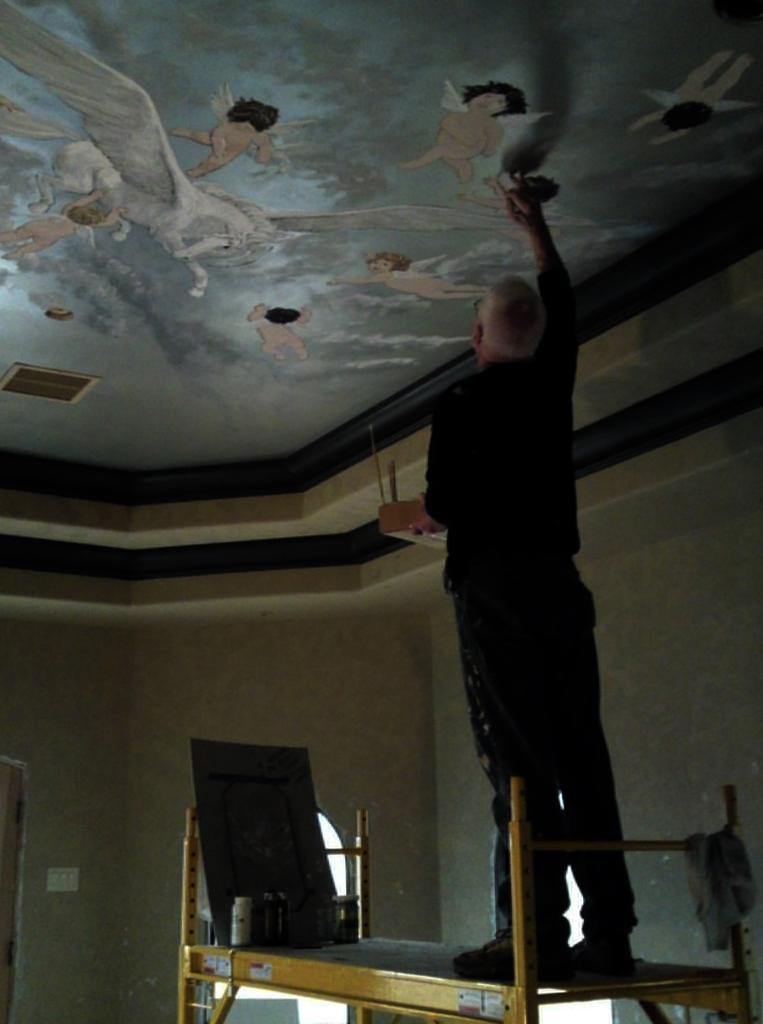In one or two sentences, can you explain what this image depicts? In the Image i can see a person standing on the table on which there are some things and painting the roof. 